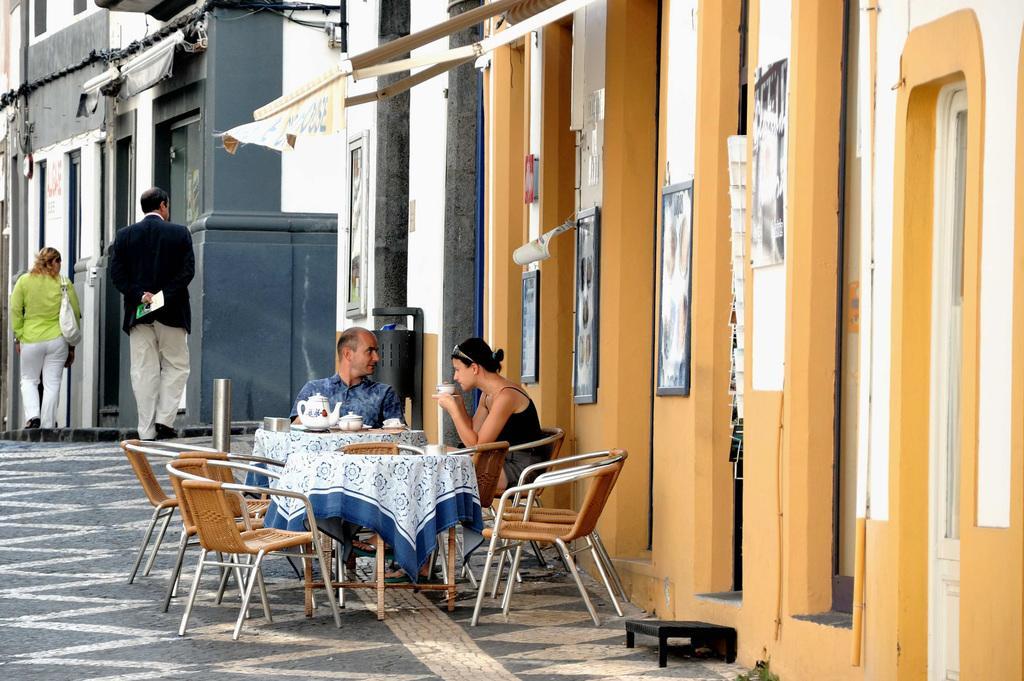Describe this image in one or two sentences. In this picture we can see one man and woman are sitting on chairs where woman is drinking and in front of them on table we have tea pot, bowl, cup, saucer and in the background we can see one woman and man are walking on footpath, building, pipes, sunshade. 